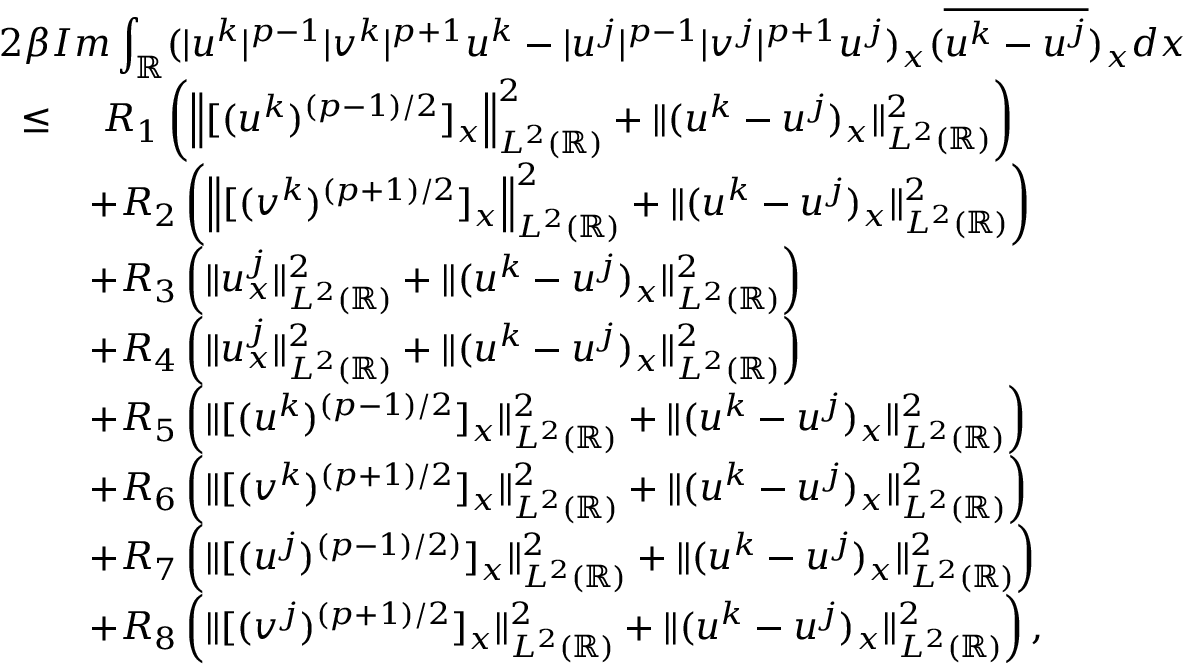<formula> <loc_0><loc_0><loc_500><loc_500>\begin{array} { r l } { 2 \beta { I m \int _ { \mathbb { R } } ( | u ^ { k } | ^ { p - 1 } | v ^ { k } | ^ { p + 1 } u ^ { k } - | u ^ { j } | ^ { p - 1 } | v ^ { j } | ^ { p + 1 } u ^ { j } ) _ { x } ( \overline { { u ^ { k } - u ^ { j } } } ) _ { x } d x } } \\ { \leq } & { \ R _ { 1 } \left ( \left \| [ ( u ^ { k } ) ^ { ( p - 1 ) / 2 } ] _ { x } \right \| _ { L ^ { 2 } ( \mathbb { R } ) } ^ { 2 } + \| ( u ^ { k } - u ^ { j } ) _ { x } \| _ { L ^ { 2 } ( \mathbb { R } ) } ^ { 2 } \right ) } \\ & { + R _ { 2 } \left ( \left \| [ ( v ^ { k } ) ^ { ( p + 1 ) / 2 } ] _ { x } \right \| _ { L ^ { 2 } ( \mathbb { R } ) } ^ { 2 } + \| ( u ^ { k } - u ^ { j } ) _ { x } \| _ { L ^ { 2 } ( \mathbb { R } ) } ^ { 2 } \right ) } \\ & { + R _ { 3 } \left ( \| u _ { x } ^ { j } \| _ { L ^ { 2 } ( \mathbb { R } ) } ^ { 2 } + \| ( u ^ { k } - u ^ { j } ) _ { x } \| _ { L ^ { 2 } ( \mathbb { R } ) } ^ { 2 } \right ) } \\ & { + R _ { 4 } \left ( \| u _ { x } ^ { j } \| _ { L ^ { 2 } ( \mathbb { R } ) } ^ { 2 } + \| ( u ^ { k } - u ^ { j } ) _ { x } \| _ { L ^ { 2 } ( \mathbb { R } ) } ^ { 2 } \right ) } \\ & { + R _ { 5 } \left ( \| [ ( u ^ { k } ) ^ { ( p - 1 ) / 2 } ] _ { x } \| _ { L ^ { 2 } ( \mathbb { R } ) } ^ { 2 } + \| ( u ^ { k } - u ^ { j } ) _ { x } \| _ { L ^ { 2 } ( \mathbb { R } ) } ^ { 2 } \right ) } \\ & { + R _ { 6 } \left ( \| [ ( v ^ { k } ) ^ { ( p + 1 ) / 2 } ] _ { x } \| _ { L ^ { 2 } ( \mathbb { R } ) } ^ { 2 } + \| ( u ^ { k } - u ^ { j } ) _ { x } \| _ { L ^ { 2 } ( \mathbb { R } ) } ^ { 2 } \right ) } \\ & { + R _ { 7 } \left ( \| [ ( u ^ { j } ) ^ { ( p - 1 ) / 2 ) } ] _ { x } \| _ { L ^ { 2 } ( \mathbb { R } ) } ^ { 2 } + \| ( u ^ { k } - u ^ { j } ) _ { x } \| _ { L ^ { 2 } ( \mathbb { R } ) } ^ { 2 } \right ) } \\ & { + R _ { 8 } \left ( \| [ ( v ^ { j } ) ^ { ( p + 1 ) / 2 } ] _ { x } \| _ { L ^ { 2 } ( \mathbb { R } ) } ^ { 2 } + \| ( u ^ { k } - u ^ { j } ) _ { x } \| _ { L ^ { 2 } ( \mathbb { R } ) } ^ { 2 } \right ) , } \end{array}</formula> 